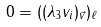Convert formula to latex. <formula><loc_0><loc_0><loc_500><loc_500>0 = ( ( \lambda _ { 3 } v _ { i } ) _ { \vec { v } } ) _ { \ell }</formula> 